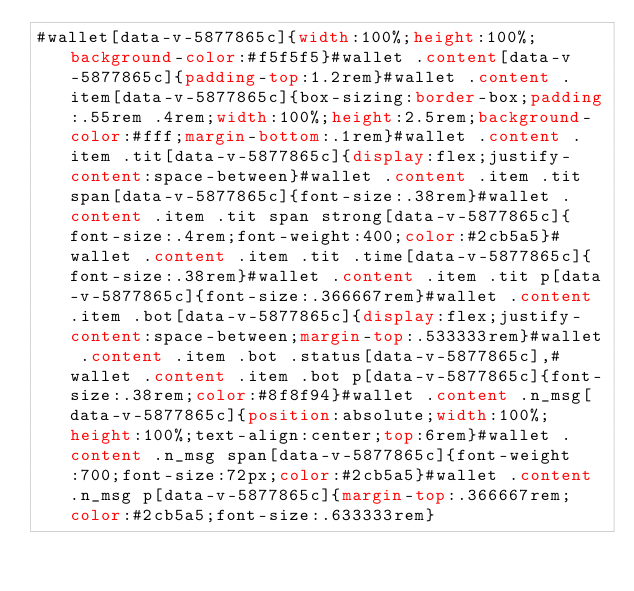<code> <loc_0><loc_0><loc_500><loc_500><_CSS_>#wallet[data-v-5877865c]{width:100%;height:100%;background-color:#f5f5f5}#wallet .content[data-v-5877865c]{padding-top:1.2rem}#wallet .content .item[data-v-5877865c]{box-sizing:border-box;padding:.55rem .4rem;width:100%;height:2.5rem;background-color:#fff;margin-bottom:.1rem}#wallet .content .item .tit[data-v-5877865c]{display:flex;justify-content:space-between}#wallet .content .item .tit span[data-v-5877865c]{font-size:.38rem}#wallet .content .item .tit span strong[data-v-5877865c]{font-size:.4rem;font-weight:400;color:#2cb5a5}#wallet .content .item .tit .time[data-v-5877865c]{font-size:.38rem}#wallet .content .item .tit p[data-v-5877865c]{font-size:.366667rem}#wallet .content .item .bot[data-v-5877865c]{display:flex;justify-content:space-between;margin-top:.533333rem}#wallet .content .item .bot .status[data-v-5877865c],#wallet .content .item .bot p[data-v-5877865c]{font-size:.38rem;color:#8f8f94}#wallet .content .n_msg[data-v-5877865c]{position:absolute;width:100%;height:100%;text-align:center;top:6rem}#wallet .content .n_msg span[data-v-5877865c]{font-weight:700;font-size:72px;color:#2cb5a5}#wallet .content .n_msg p[data-v-5877865c]{margin-top:.366667rem;color:#2cb5a5;font-size:.633333rem}</code> 